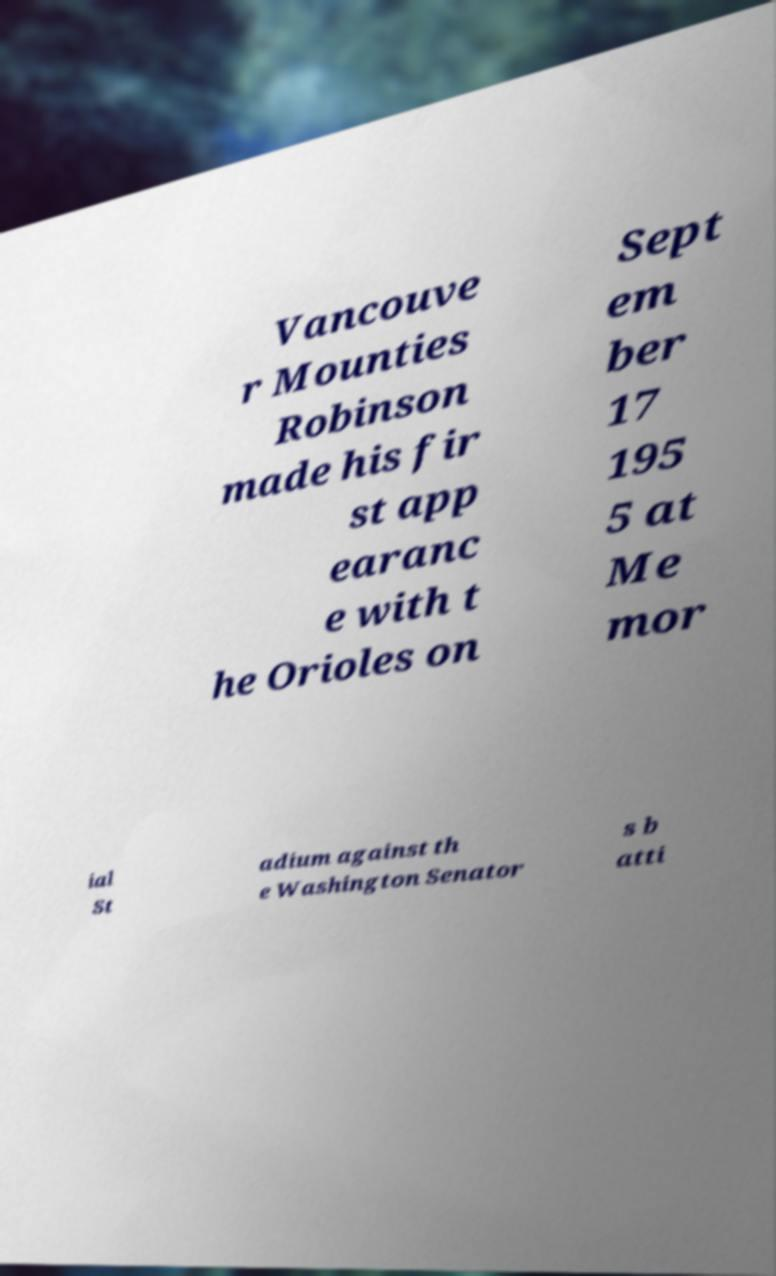For documentation purposes, I need the text within this image transcribed. Could you provide that? Vancouve r Mounties Robinson made his fir st app earanc e with t he Orioles on Sept em ber 17 195 5 at Me mor ial St adium against th e Washington Senator s b atti 